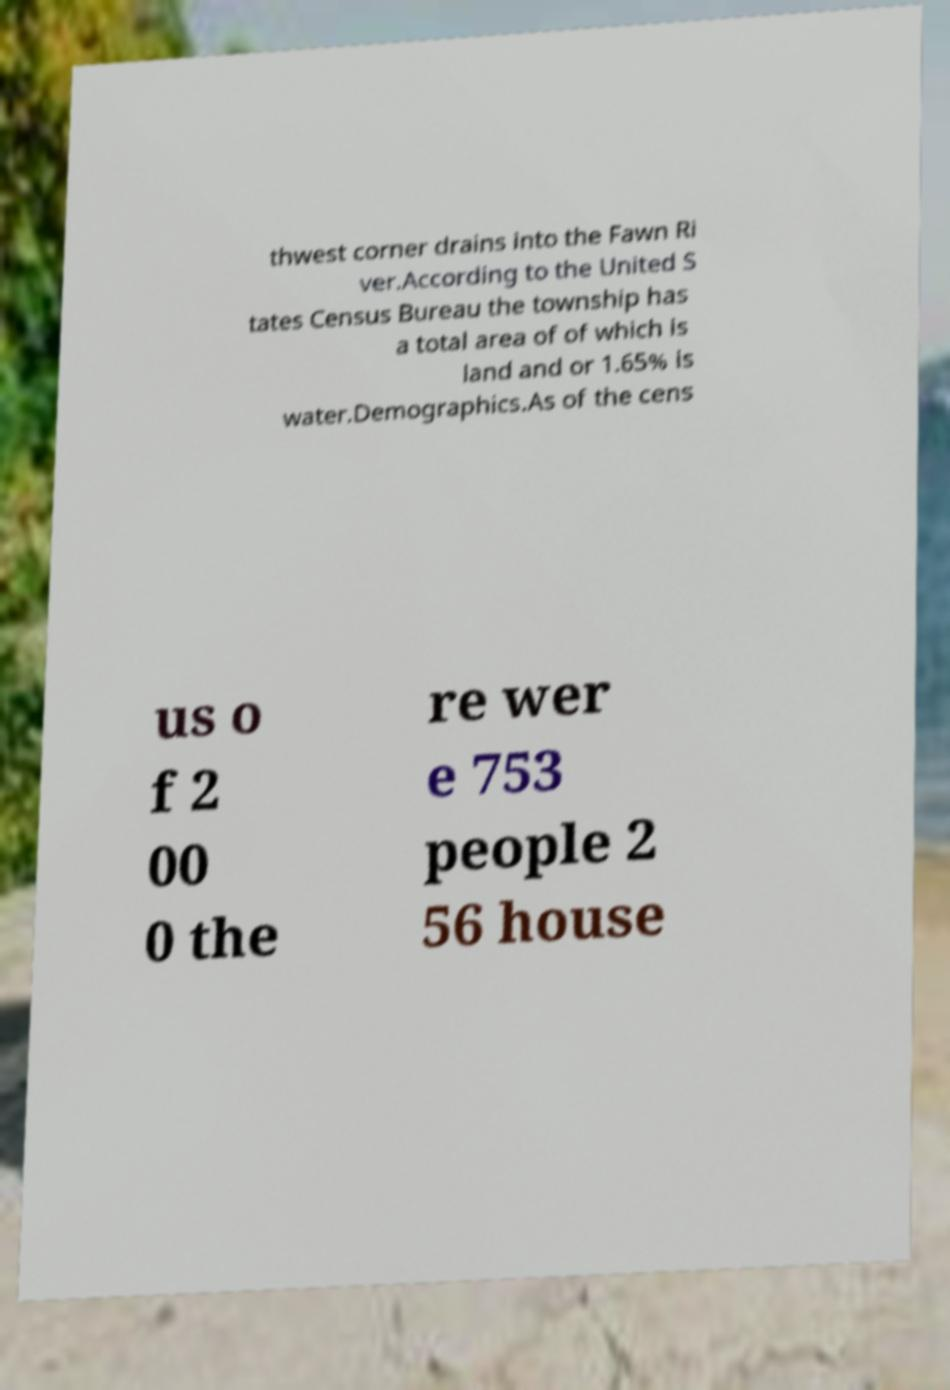Can you read and provide the text displayed in the image?This photo seems to have some interesting text. Can you extract and type it out for me? thwest corner drains into the Fawn Ri ver.According to the United S tates Census Bureau the township has a total area of of which is land and or 1.65% is water.Demographics.As of the cens us o f 2 00 0 the re wer e 753 people 2 56 house 